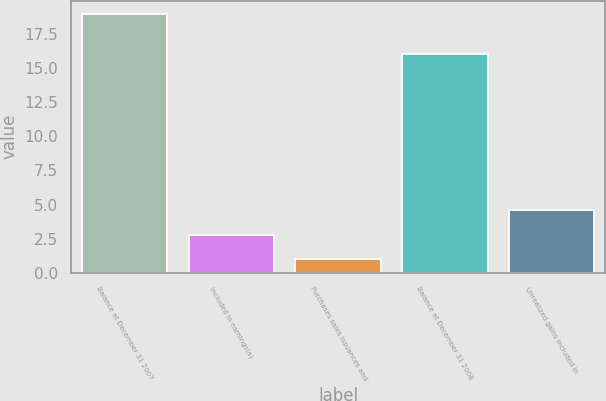Convert chart. <chart><loc_0><loc_0><loc_500><loc_500><bar_chart><fcel>Balance at December 31 2007<fcel>Included in earnings(a)<fcel>Purchases sales issuances and<fcel>Balance at December 31 2008<fcel>Unrealized gains included in<nl><fcel>19<fcel>2.8<fcel>1<fcel>16<fcel>4.6<nl></chart> 